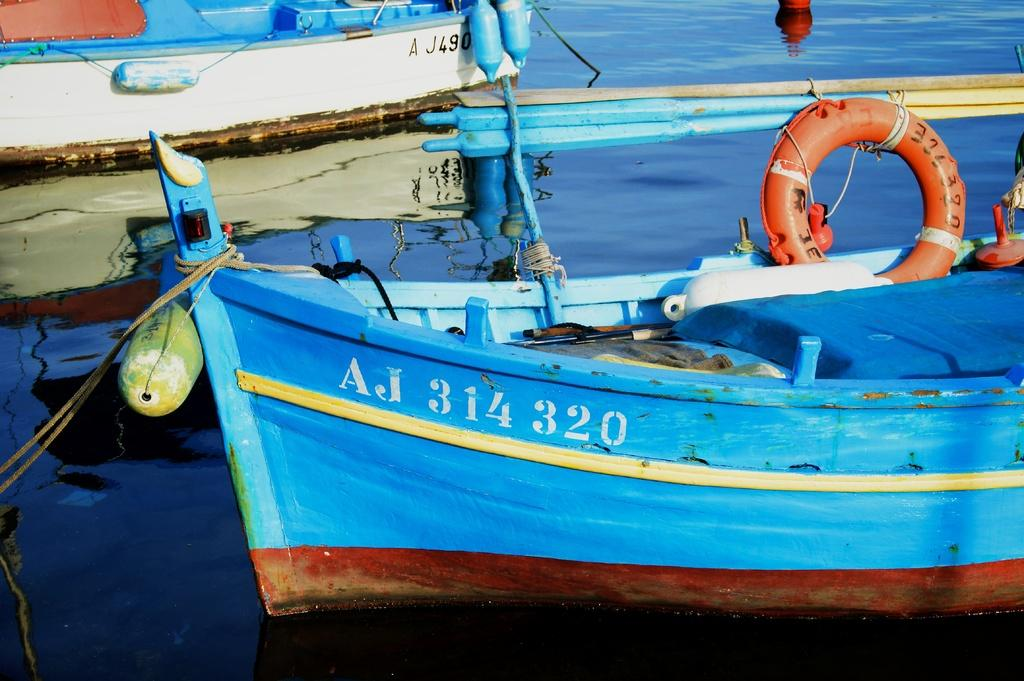<image>
Offer a succinct explanation of the picture presented. A blue rowboat is tied to the dock and it says AJ 314 320 on the side. 